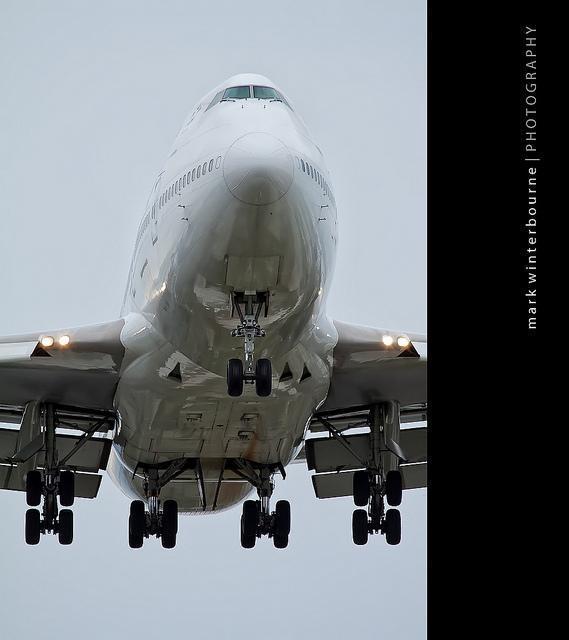How many wheels are on the plane?
Give a very brief answer. 12. How many planes in the sky?
Give a very brief answer. 1. 